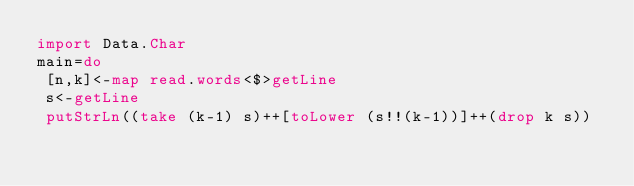<code> <loc_0><loc_0><loc_500><loc_500><_Haskell_>import Data.Char
main=do
 [n,k]<-map read.words<$>getLine
 s<-getLine
 putStrLn((take (k-1) s)++[toLower (s!!(k-1))]++(drop k s))</code> 